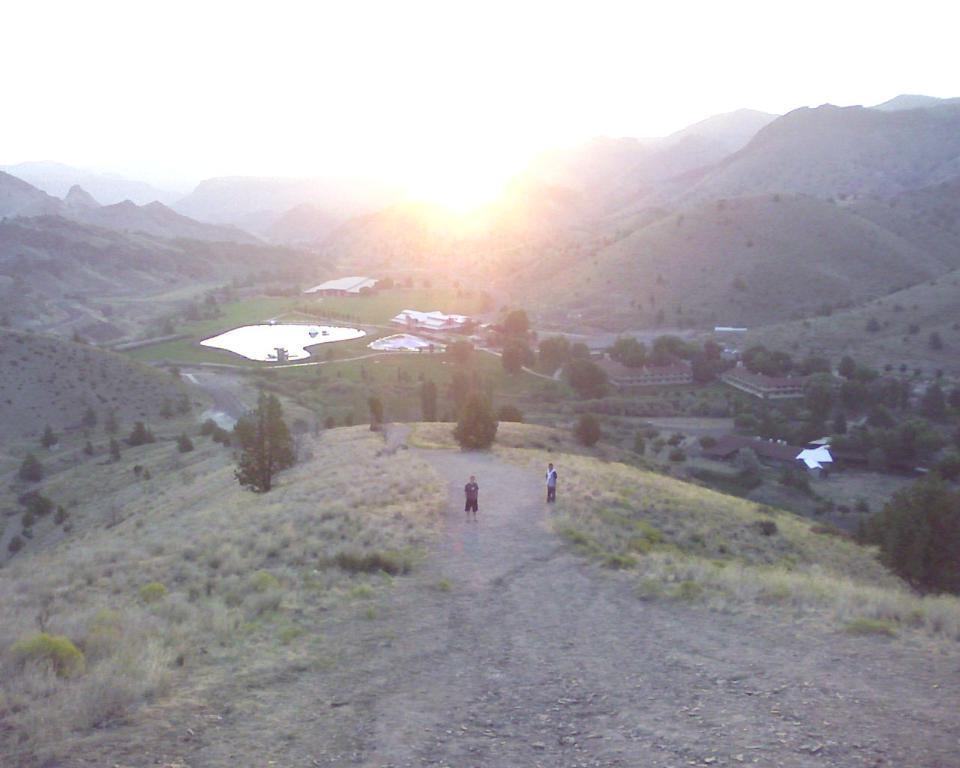In one or two sentences, can you explain what this image depicts? In this picture there are people standing and we can see grass, trees, buildings, water and hills. In the background of the image we can see the sky. 